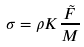Convert formula to latex. <formula><loc_0><loc_0><loc_500><loc_500>\sigma = \rho K \frac { \tilde { F } } { M }</formula> 